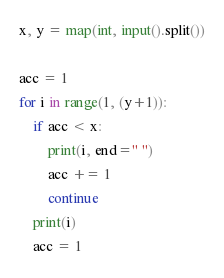<code> <loc_0><loc_0><loc_500><loc_500><_Python_>x, y = map(int, input().split())

acc = 1
for i in range(1, (y+1)):
    if acc < x:
        print(i, end=" ")
        acc += 1
        continue
    print(i)
    acc = 1</code> 